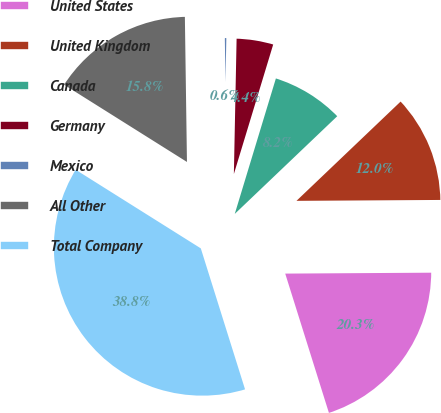Convert chart to OTSL. <chart><loc_0><loc_0><loc_500><loc_500><pie_chart><fcel>United States<fcel>United Kingdom<fcel>Canada<fcel>Germany<fcel>Mexico<fcel>All Other<fcel>Total Company<nl><fcel>20.26%<fcel>12.02%<fcel>8.19%<fcel>4.37%<fcel>0.55%<fcel>15.84%<fcel>38.77%<nl></chart> 